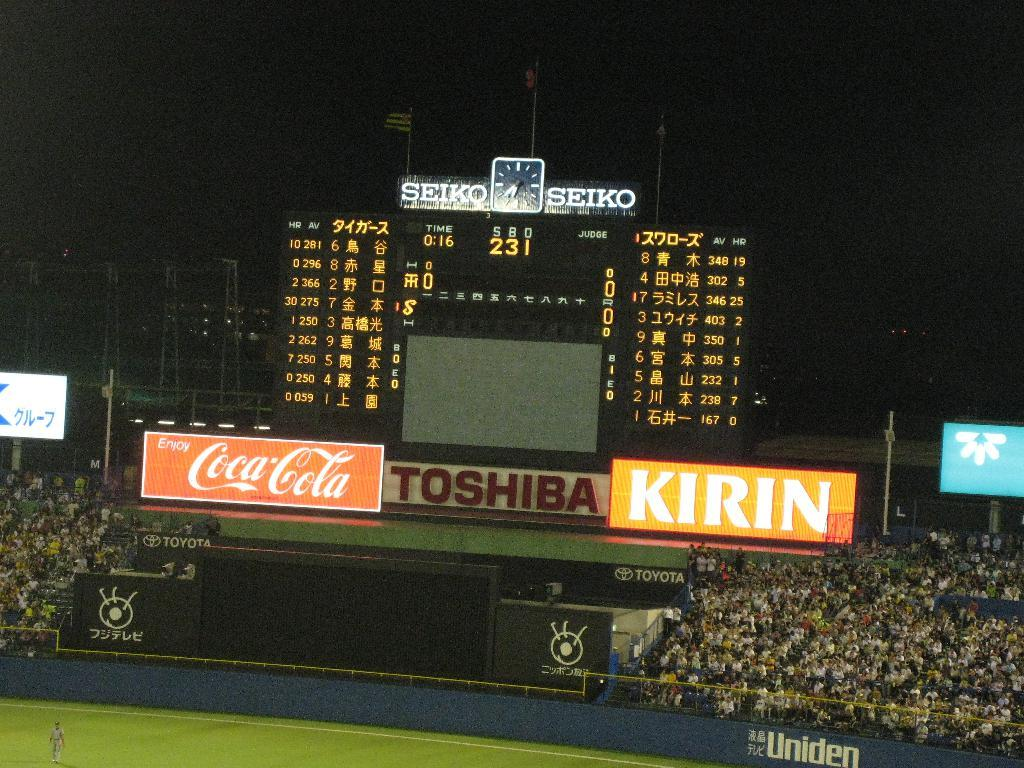Provide a one-sentence caption for the provided image. The image features sponsorships from Toshiba and Kirin. 